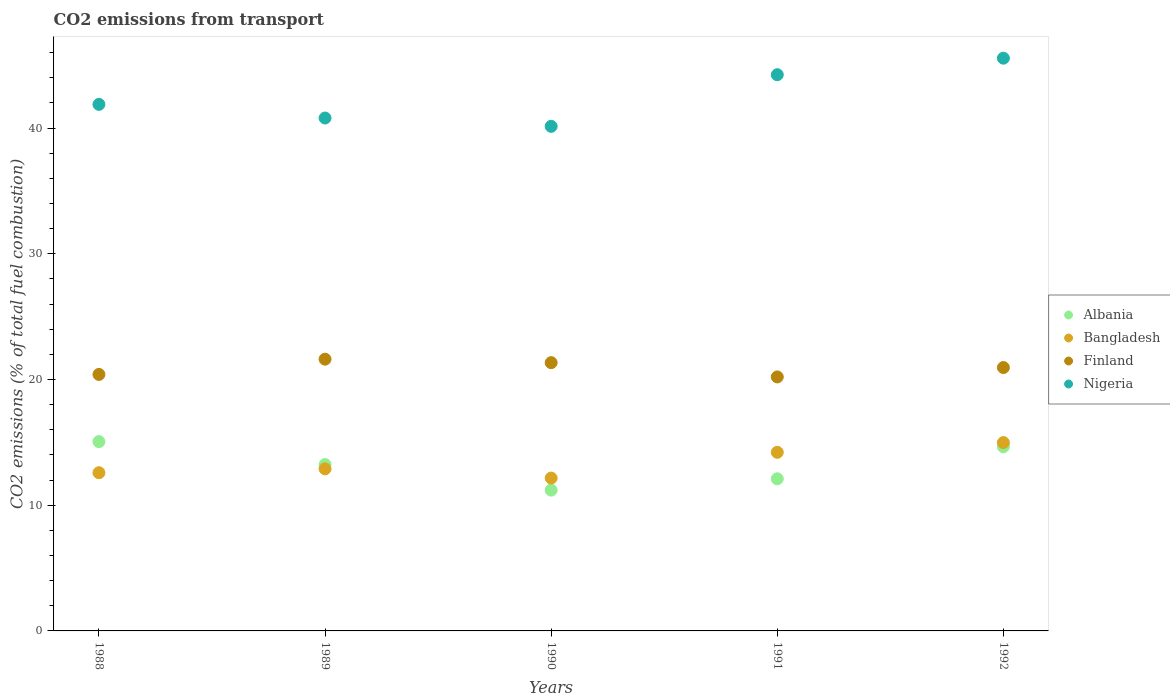What is the total CO2 emitted in Nigeria in 1988?
Give a very brief answer. 41.88. Across all years, what is the maximum total CO2 emitted in Nigeria?
Offer a very short reply. 45.56. Across all years, what is the minimum total CO2 emitted in Finland?
Offer a terse response. 20.2. In which year was the total CO2 emitted in Nigeria maximum?
Your response must be concise. 1992. In which year was the total CO2 emitted in Bangladesh minimum?
Offer a terse response. 1990. What is the total total CO2 emitted in Nigeria in the graph?
Your response must be concise. 212.63. What is the difference between the total CO2 emitted in Finland in 1990 and that in 1992?
Keep it short and to the point. 0.39. What is the difference between the total CO2 emitted in Albania in 1992 and the total CO2 emitted in Finland in 1990?
Your answer should be compact. -6.69. What is the average total CO2 emitted in Finland per year?
Offer a terse response. 20.9. In the year 1991, what is the difference between the total CO2 emitted in Finland and total CO2 emitted in Bangladesh?
Give a very brief answer. 6. In how many years, is the total CO2 emitted in Nigeria greater than 2?
Make the answer very short. 5. What is the ratio of the total CO2 emitted in Bangladesh in 1989 to that in 1992?
Offer a very short reply. 0.86. Is the total CO2 emitted in Bangladesh in 1989 less than that in 1992?
Your answer should be very brief. Yes. What is the difference between the highest and the second highest total CO2 emitted in Finland?
Your answer should be very brief. 0.28. What is the difference between the highest and the lowest total CO2 emitted in Albania?
Make the answer very short. 3.86. Is the sum of the total CO2 emitted in Nigeria in 1988 and 1990 greater than the maximum total CO2 emitted in Albania across all years?
Ensure brevity in your answer.  Yes. Is the total CO2 emitted in Nigeria strictly greater than the total CO2 emitted in Bangladesh over the years?
Offer a very short reply. Yes. Is the total CO2 emitted in Bangladesh strictly less than the total CO2 emitted in Nigeria over the years?
Offer a terse response. Yes. How many dotlines are there?
Offer a very short reply. 4. How many years are there in the graph?
Provide a short and direct response. 5. Are the values on the major ticks of Y-axis written in scientific E-notation?
Ensure brevity in your answer.  No. Does the graph contain any zero values?
Offer a very short reply. No. How many legend labels are there?
Offer a very short reply. 4. How are the legend labels stacked?
Make the answer very short. Vertical. What is the title of the graph?
Provide a short and direct response. CO2 emissions from transport. Does "Nigeria" appear as one of the legend labels in the graph?
Offer a very short reply. Yes. What is the label or title of the Y-axis?
Your answer should be compact. CO2 emissions (% of total fuel combustion). What is the CO2 emissions (% of total fuel combustion) of Albania in 1988?
Offer a very short reply. 15.06. What is the CO2 emissions (% of total fuel combustion) in Bangladesh in 1988?
Provide a short and direct response. 12.58. What is the CO2 emissions (% of total fuel combustion) in Finland in 1988?
Your answer should be compact. 20.4. What is the CO2 emissions (% of total fuel combustion) in Nigeria in 1988?
Your response must be concise. 41.88. What is the CO2 emissions (% of total fuel combustion) in Albania in 1989?
Keep it short and to the point. 13.23. What is the CO2 emissions (% of total fuel combustion) in Bangladesh in 1989?
Keep it short and to the point. 12.9. What is the CO2 emissions (% of total fuel combustion) in Finland in 1989?
Keep it short and to the point. 21.62. What is the CO2 emissions (% of total fuel combustion) in Nigeria in 1989?
Ensure brevity in your answer.  40.8. What is the CO2 emissions (% of total fuel combustion) of Bangladesh in 1990?
Provide a short and direct response. 12.16. What is the CO2 emissions (% of total fuel combustion) of Finland in 1990?
Provide a short and direct response. 21.34. What is the CO2 emissions (% of total fuel combustion) of Nigeria in 1990?
Keep it short and to the point. 40.14. What is the CO2 emissions (% of total fuel combustion) of Albania in 1991?
Your answer should be very brief. 12.1. What is the CO2 emissions (% of total fuel combustion) in Bangladesh in 1991?
Offer a terse response. 14.21. What is the CO2 emissions (% of total fuel combustion) of Finland in 1991?
Offer a very short reply. 20.2. What is the CO2 emissions (% of total fuel combustion) of Nigeria in 1991?
Make the answer very short. 44.24. What is the CO2 emissions (% of total fuel combustion) in Albania in 1992?
Provide a succinct answer. 14.65. What is the CO2 emissions (% of total fuel combustion) in Bangladesh in 1992?
Your response must be concise. 14.98. What is the CO2 emissions (% of total fuel combustion) of Finland in 1992?
Offer a very short reply. 20.95. What is the CO2 emissions (% of total fuel combustion) in Nigeria in 1992?
Your answer should be very brief. 45.56. Across all years, what is the maximum CO2 emissions (% of total fuel combustion) in Albania?
Make the answer very short. 15.06. Across all years, what is the maximum CO2 emissions (% of total fuel combustion) of Bangladesh?
Ensure brevity in your answer.  14.98. Across all years, what is the maximum CO2 emissions (% of total fuel combustion) in Finland?
Your response must be concise. 21.62. Across all years, what is the maximum CO2 emissions (% of total fuel combustion) of Nigeria?
Provide a succinct answer. 45.56. Across all years, what is the minimum CO2 emissions (% of total fuel combustion) in Albania?
Your answer should be compact. 11.2. Across all years, what is the minimum CO2 emissions (% of total fuel combustion) of Bangladesh?
Your answer should be compact. 12.16. Across all years, what is the minimum CO2 emissions (% of total fuel combustion) in Finland?
Your answer should be very brief. 20.2. Across all years, what is the minimum CO2 emissions (% of total fuel combustion) of Nigeria?
Provide a succinct answer. 40.14. What is the total CO2 emissions (% of total fuel combustion) of Albania in the graph?
Your answer should be compact. 66.24. What is the total CO2 emissions (% of total fuel combustion) in Bangladesh in the graph?
Your answer should be very brief. 66.83. What is the total CO2 emissions (% of total fuel combustion) of Finland in the graph?
Your answer should be very brief. 104.51. What is the total CO2 emissions (% of total fuel combustion) of Nigeria in the graph?
Give a very brief answer. 212.63. What is the difference between the CO2 emissions (% of total fuel combustion) of Albania in 1988 and that in 1989?
Your response must be concise. 1.83. What is the difference between the CO2 emissions (% of total fuel combustion) of Bangladesh in 1988 and that in 1989?
Give a very brief answer. -0.31. What is the difference between the CO2 emissions (% of total fuel combustion) of Finland in 1988 and that in 1989?
Keep it short and to the point. -1.21. What is the difference between the CO2 emissions (% of total fuel combustion) of Nigeria in 1988 and that in 1989?
Offer a terse response. 1.09. What is the difference between the CO2 emissions (% of total fuel combustion) of Albania in 1988 and that in 1990?
Your response must be concise. 3.86. What is the difference between the CO2 emissions (% of total fuel combustion) in Bangladesh in 1988 and that in 1990?
Ensure brevity in your answer.  0.43. What is the difference between the CO2 emissions (% of total fuel combustion) of Finland in 1988 and that in 1990?
Offer a very short reply. -0.94. What is the difference between the CO2 emissions (% of total fuel combustion) in Nigeria in 1988 and that in 1990?
Offer a terse response. 1.75. What is the difference between the CO2 emissions (% of total fuel combustion) in Albania in 1988 and that in 1991?
Offer a terse response. 2.96. What is the difference between the CO2 emissions (% of total fuel combustion) of Bangladesh in 1988 and that in 1991?
Provide a succinct answer. -1.62. What is the difference between the CO2 emissions (% of total fuel combustion) of Finland in 1988 and that in 1991?
Your response must be concise. 0.2. What is the difference between the CO2 emissions (% of total fuel combustion) in Nigeria in 1988 and that in 1991?
Your answer should be compact. -2.36. What is the difference between the CO2 emissions (% of total fuel combustion) of Albania in 1988 and that in 1992?
Make the answer very short. 0.41. What is the difference between the CO2 emissions (% of total fuel combustion) in Bangladesh in 1988 and that in 1992?
Make the answer very short. -2.4. What is the difference between the CO2 emissions (% of total fuel combustion) in Finland in 1988 and that in 1992?
Make the answer very short. -0.55. What is the difference between the CO2 emissions (% of total fuel combustion) in Nigeria in 1988 and that in 1992?
Make the answer very short. -3.67. What is the difference between the CO2 emissions (% of total fuel combustion) in Albania in 1989 and that in 1990?
Your answer should be compact. 2.03. What is the difference between the CO2 emissions (% of total fuel combustion) of Bangladesh in 1989 and that in 1990?
Provide a short and direct response. 0.74. What is the difference between the CO2 emissions (% of total fuel combustion) of Finland in 1989 and that in 1990?
Offer a very short reply. 0.28. What is the difference between the CO2 emissions (% of total fuel combustion) of Nigeria in 1989 and that in 1990?
Offer a very short reply. 0.66. What is the difference between the CO2 emissions (% of total fuel combustion) in Albania in 1989 and that in 1991?
Keep it short and to the point. 1.13. What is the difference between the CO2 emissions (% of total fuel combustion) of Bangladesh in 1989 and that in 1991?
Your answer should be very brief. -1.31. What is the difference between the CO2 emissions (% of total fuel combustion) of Finland in 1989 and that in 1991?
Your answer should be very brief. 1.41. What is the difference between the CO2 emissions (% of total fuel combustion) in Nigeria in 1989 and that in 1991?
Your response must be concise. -3.44. What is the difference between the CO2 emissions (% of total fuel combustion) in Albania in 1989 and that in 1992?
Ensure brevity in your answer.  -1.42. What is the difference between the CO2 emissions (% of total fuel combustion) in Bangladesh in 1989 and that in 1992?
Your answer should be very brief. -2.09. What is the difference between the CO2 emissions (% of total fuel combustion) in Finland in 1989 and that in 1992?
Offer a terse response. 0.67. What is the difference between the CO2 emissions (% of total fuel combustion) in Nigeria in 1989 and that in 1992?
Ensure brevity in your answer.  -4.76. What is the difference between the CO2 emissions (% of total fuel combustion) of Albania in 1990 and that in 1991?
Ensure brevity in your answer.  -0.9. What is the difference between the CO2 emissions (% of total fuel combustion) of Bangladesh in 1990 and that in 1991?
Keep it short and to the point. -2.05. What is the difference between the CO2 emissions (% of total fuel combustion) of Finland in 1990 and that in 1991?
Your answer should be compact. 1.14. What is the difference between the CO2 emissions (% of total fuel combustion) in Nigeria in 1990 and that in 1991?
Provide a short and direct response. -4.11. What is the difference between the CO2 emissions (% of total fuel combustion) of Albania in 1990 and that in 1992?
Offer a terse response. -3.45. What is the difference between the CO2 emissions (% of total fuel combustion) in Bangladesh in 1990 and that in 1992?
Your answer should be compact. -2.82. What is the difference between the CO2 emissions (% of total fuel combustion) in Finland in 1990 and that in 1992?
Ensure brevity in your answer.  0.39. What is the difference between the CO2 emissions (% of total fuel combustion) in Nigeria in 1990 and that in 1992?
Offer a very short reply. -5.42. What is the difference between the CO2 emissions (% of total fuel combustion) in Albania in 1991 and that in 1992?
Give a very brief answer. -2.55. What is the difference between the CO2 emissions (% of total fuel combustion) in Bangladesh in 1991 and that in 1992?
Your answer should be very brief. -0.77. What is the difference between the CO2 emissions (% of total fuel combustion) in Finland in 1991 and that in 1992?
Your answer should be very brief. -0.75. What is the difference between the CO2 emissions (% of total fuel combustion) of Nigeria in 1991 and that in 1992?
Make the answer very short. -1.32. What is the difference between the CO2 emissions (% of total fuel combustion) of Albania in 1988 and the CO2 emissions (% of total fuel combustion) of Bangladesh in 1989?
Make the answer very short. 2.16. What is the difference between the CO2 emissions (% of total fuel combustion) of Albania in 1988 and the CO2 emissions (% of total fuel combustion) of Finland in 1989?
Give a very brief answer. -6.56. What is the difference between the CO2 emissions (% of total fuel combustion) in Albania in 1988 and the CO2 emissions (% of total fuel combustion) in Nigeria in 1989?
Your response must be concise. -25.74. What is the difference between the CO2 emissions (% of total fuel combustion) of Bangladesh in 1988 and the CO2 emissions (% of total fuel combustion) of Finland in 1989?
Provide a succinct answer. -9.03. What is the difference between the CO2 emissions (% of total fuel combustion) of Bangladesh in 1988 and the CO2 emissions (% of total fuel combustion) of Nigeria in 1989?
Your response must be concise. -28.21. What is the difference between the CO2 emissions (% of total fuel combustion) in Finland in 1988 and the CO2 emissions (% of total fuel combustion) in Nigeria in 1989?
Keep it short and to the point. -20.4. What is the difference between the CO2 emissions (% of total fuel combustion) in Albania in 1988 and the CO2 emissions (% of total fuel combustion) in Bangladesh in 1990?
Give a very brief answer. 2.9. What is the difference between the CO2 emissions (% of total fuel combustion) in Albania in 1988 and the CO2 emissions (% of total fuel combustion) in Finland in 1990?
Provide a succinct answer. -6.28. What is the difference between the CO2 emissions (% of total fuel combustion) in Albania in 1988 and the CO2 emissions (% of total fuel combustion) in Nigeria in 1990?
Provide a short and direct response. -25.08. What is the difference between the CO2 emissions (% of total fuel combustion) in Bangladesh in 1988 and the CO2 emissions (% of total fuel combustion) in Finland in 1990?
Ensure brevity in your answer.  -8.75. What is the difference between the CO2 emissions (% of total fuel combustion) in Bangladesh in 1988 and the CO2 emissions (% of total fuel combustion) in Nigeria in 1990?
Provide a short and direct response. -27.55. What is the difference between the CO2 emissions (% of total fuel combustion) of Finland in 1988 and the CO2 emissions (% of total fuel combustion) of Nigeria in 1990?
Offer a very short reply. -19.74. What is the difference between the CO2 emissions (% of total fuel combustion) in Albania in 1988 and the CO2 emissions (% of total fuel combustion) in Bangladesh in 1991?
Provide a short and direct response. 0.85. What is the difference between the CO2 emissions (% of total fuel combustion) in Albania in 1988 and the CO2 emissions (% of total fuel combustion) in Finland in 1991?
Offer a very short reply. -5.14. What is the difference between the CO2 emissions (% of total fuel combustion) of Albania in 1988 and the CO2 emissions (% of total fuel combustion) of Nigeria in 1991?
Your answer should be very brief. -29.18. What is the difference between the CO2 emissions (% of total fuel combustion) of Bangladesh in 1988 and the CO2 emissions (% of total fuel combustion) of Finland in 1991?
Make the answer very short. -7.62. What is the difference between the CO2 emissions (% of total fuel combustion) of Bangladesh in 1988 and the CO2 emissions (% of total fuel combustion) of Nigeria in 1991?
Provide a short and direct response. -31.66. What is the difference between the CO2 emissions (% of total fuel combustion) in Finland in 1988 and the CO2 emissions (% of total fuel combustion) in Nigeria in 1991?
Provide a succinct answer. -23.84. What is the difference between the CO2 emissions (% of total fuel combustion) of Albania in 1988 and the CO2 emissions (% of total fuel combustion) of Bangladesh in 1992?
Your answer should be very brief. 0.08. What is the difference between the CO2 emissions (% of total fuel combustion) in Albania in 1988 and the CO2 emissions (% of total fuel combustion) in Finland in 1992?
Make the answer very short. -5.89. What is the difference between the CO2 emissions (% of total fuel combustion) of Albania in 1988 and the CO2 emissions (% of total fuel combustion) of Nigeria in 1992?
Make the answer very short. -30.5. What is the difference between the CO2 emissions (% of total fuel combustion) in Bangladesh in 1988 and the CO2 emissions (% of total fuel combustion) in Finland in 1992?
Provide a succinct answer. -8.37. What is the difference between the CO2 emissions (% of total fuel combustion) of Bangladesh in 1988 and the CO2 emissions (% of total fuel combustion) of Nigeria in 1992?
Keep it short and to the point. -32.98. What is the difference between the CO2 emissions (% of total fuel combustion) of Finland in 1988 and the CO2 emissions (% of total fuel combustion) of Nigeria in 1992?
Your answer should be very brief. -25.16. What is the difference between the CO2 emissions (% of total fuel combustion) of Albania in 1989 and the CO2 emissions (% of total fuel combustion) of Bangladesh in 1990?
Ensure brevity in your answer.  1.07. What is the difference between the CO2 emissions (% of total fuel combustion) in Albania in 1989 and the CO2 emissions (% of total fuel combustion) in Finland in 1990?
Provide a short and direct response. -8.11. What is the difference between the CO2 emissions (% of total fuel combustion) of Albania in 1989 and the CO2 emissions (% of total fuel combustion) of Nigeria in 1990?
Provide a short and direct response. -26.91. What is the difference between the CO2 emissions (% of total fuel combustion) in Bangladesh in 1989 and the CO2 emissions (% of total fuel combustion) in Finland in 1990?
Offer a very short reply. -8.44. What is the difference between the CO2 emissions (% of total fuel combustion) in Bangladesh in 1989 and the CO2 emissions (% of total fuel combustion) in Nigeria in 1990?
Keep it short and to the point. -27.24. What is the difference between the CO2 emissions (% of total fuel combustion) in Finland in 1989 and the CO2 emissions (% of total fuel combustion) in Nigeria in 1990?
Your response must be concise. -18.52. What is the difference between the CO2 emissions (% of total fuel combustion) in Albania in 1989 and the CO2 emissions (% of total fuel combustion) in Bangladesh in 1991?
Your answer should be compact. -0.98. What is the difference between the CO2 emissions (% of total fuel combustion) of Albania in 1989 and the CO2 emissions (% of total fuel combustion) of Finland in 1991?
Make the answer very short. -6.97. What is the difference between the CO2 emissions (% of total fuel combustion) of Albania in 1989 and the CO2 emissions (% of total fuel combustion) of Nigeria in 1991?
Provide a short and direct response. -31.01. What is the difference between the CO2 emissions (% of total fuel combustion) of Bangladesh in 1989 and the CO2 emissions (% of total fuel combustion) of Finland in 1991?
Offer a very short reply. -7.31. What is the difference between the CO2 emissions (% of total fuel combustion) of Bangladesh in 1989 and the CO2 emissions (% of total fuel combustion) of Nigeria in 1991?
Provide a succinct answer. -31.35. What is the difference between the CO2 emissions (% of total fuel combustion) in Finland in 1989 and the CO2 emissions (% of total fuel combustion) in Nigeria in 1991?
Provide a succinct answer. -22.63. What is the difference between the CO2 emissions (% of total fuel combustion) of Albania in 1989 and the CO2 emissions (% of total fuel combustion) of Bangladesh in 1992?
Ensure brevity in your answer.  -1.75. What is the difference between the CO2 emissions (% of total fuel combustion) of Albania in 1989 and the CO2 emissions (% of total fuel combustion) of Finland in 1992?
Your answer should be compact. -7.72. What is the difference between the CO2 emissions (% of total fuel combustion) of Albania in 1989 and the CO2 emissions (% of total fuel combustion) of Nigeria in 1992?
Ensure brevity in your answer.  -32.33. What is the difference between the CO2 emissions (% of total fuel combustion) of Bangladesh in 1989 and the CO2 emissions (% of total fuel combustion) of Finland in 1992?
Make the answer very short. -8.05. What is the difference between the CO2 emissions (% of total fuel combustion) in Bangladesh in 1989 and the CO2 emissions (% of total fuel combustion) in Nigeria in 1992?
Your answer should be very brief. -32.66. What is the difference between the CO2 emissions (% of total fuel combustion) in Finland in 1989 and the CO2 emissions (% of total fuel combustion) in Nigeria in 1992?
Offer a very short reply. -23.94. What is the difference between the CO2 emissions (% of total fuel combustion) in Albania in 1990 and the CO2 emissions (% of total fuel combustion) in Bangladesh in 1991?
Give a very brief answer. -3.01. What is the difference between the CO2 emissions (% of total fuel combustion) of Albania in 1990 and the CO2 emissions (% of total fuel combustion) of Finland in 1991?
Provide a succinct answer. -9. What is the difference between the CO2 emissions (% of total fuel combustion) of Albania in 1990 and the CO2 emissions (% of total fuel combustion) of Nigeria in 1991?
Provide a short and direct response. -33.04. What is the difference between the CO2 emissions (% of total fuel combustion) of Bangladesh in 1990 and the CO2 emissions (% of total fuel combustion) of Finland in 1991?
Your answer should be very brief. -8.04. What is the difference between the CO2 emissions (% of total fuel combustion) of Bangladesh in 1990 and the CO2 emissions (% of total fuel combustion) of Nigeria in 1991?
Give a very brief answer. -32.08. What is the difference between the CO2 emissions (% of total fuel combustion) in Finland in 1990 and the CO2 emissions (% of total fuel combustion) in Nigeria in 1991?
Provide a short and direct response. -22.9. What is the difference between the CO2 emissions (% of total fuel combustion) of Albania in 1990 and the CO2 emissions (% of total fuel combustion) of Bangladesh in 1992?
Provide a succinct answer. -3.78. What is the difference between the CO2 emissions (% of total fuel combustion) of Albania in 1990 and the CO2 emissions (% of total fuel combustion) of Finland in 1992?
Your answer should be very brief. -9.75. What is the difference between the CO2 emissions (% of total fuel combustion) of Albania in 1990 and the CO2 emissions (% of total fuel combustion) of Nigeria in 1992?
Offer a very short reply. -34.36. What is the difference between the CO2 emissions (% of total fuel combustion) of Bangladesh in 1990 and the CO2 emissions (% of total fuel combustion) of Finland in 1992?
Give a very brief answer. -8.79. What is the difference between the CO2 emissions (% of total fuel combustion) of Bangladesh in 1990 and the CO2 emissions (% of total fuel combustion) of Nigeria in 1992?
Provide a succinct answer. -33.4. What is the difference between the CO2 emissions (% of total fuel combustion) of Finland in 1990 and the CO2 emissions (% of total fuel combustion) of Nigeria in 1992?
Provide a succinct answer. -24.22. What is the difference between the CO2 emissions (% of total fuel combustion) of Albania in 1991 and the CO2 emissions (% of total fuel combustion) of Bangladesh in 1992?
Ensure brevity in your answer.  -2.88. What is the difference between the CO2 emissions (% of total fuel combustion) in Albania in 1991 and the CO2 emissions (% of total fuel combustion) in Finland in 1992?
Your answer should be compact. -8.85. What is the difference between the CO2 emissions (% of total fuel combustion) of Albania in 1991 and the CO2 emissions (% of total fuel combustion) of Nigeria in 1992?
Your response must be concise. -33.46. What is the difference between the CO2 emissions (% of total fuel combustion) in Bangladesh in 1991 and the CO2 emissions (% of total fuel combustion) in Finland in 1992?
Offer a terse response. -6.74. What is the difference between the CO2 emissions (% of total fuel combustion) in Bangladesh in 1991 and the CO2 emissions (% of total fuel combustion) in Nigeria in 1992?
Your response must be concise. -31.35. What is the difference between the CO2 emissions (% of total fuel combustion) in Finland in 1991 and the CO2 emissions (% of total fuel combustion) in Nigeria in 1992?
Provide a succinct answer. -25.36. What is the average CO2 emissions (% of total fuel combustion) of Albania per year?
Ensure brevity in your answer.  13.25. What is the average CO2 emissions (% of total fuel combustion) of Bangladesh per year?
Make the answer very short. 13.37. What is the average CO2 emissions (% of total fuel combustion) in Finland per year?
Keep it short and to the point. 20.9. What is the average CO2 emissions (% of total fuel combustion) in Nigeria per year?
Ensure brevity in your answer.  42.53. In the year 1988, what is the difference between the CO2 emissions (% of total fuel combustion) in Albania and CO2 emissions (% of total fuel combustion) in Bangladesh?
Your answer should be compact. 2.48. In the year 1988, what is the difference between the CO2 emissions (% of total fuel combustion) of Albania and CO2 emissions (% of total fuel combustion) of Finland?
Provide a succinct answer. -5.34. In the year 1988, what is the difference between the CO2 emissions (% of total fuel combustion) in Albania and CO2 emissions (% of total fuel combustion) in Nigeria?
Make the answer very short. -26.83. In the year 1988, what is the difference between the CO2 emissions (% of total fuel combustion) of Bangladesh and CO2 emissions (% of total fuel combustion) of Finland?
Your answer should be compact. -7.82. In the year 1988, what is the difference between the CO2 emissions (% of total fuel combustion) of Bangladesh and CO2 emissions (% of total fuel combustion) of Nigeria?
Ensure brevity in your answer.  -29.3. In the year 1988, what is the difference between the CO2 emissions (% of total fuel combustion) of Finland and CO2 emissions (% of total fuel combustion) of Nigeria?
Provide a succinct answer. -21.48. In the year 1989, what is the difference between the CO2 emissions (% of total fuel combustion) in Albania and CO2 emissions (% of total fuel combustion) in Bangladesh?
Make the answer very short. 0.34. In the year 1989, what is the difference between the CO2 emissions (% of total fuel combustion) in Albania and CO2 emissions (% of total fuel combustion) in Finland?
Ensure brevity in your answer.  -8.39. In the year 1989, what is the difference between the CO2 emissions (% of total fuel combustion) of Albania and CO2 emissions (% of total fuel combustion) of Nigeria?
Make the answer very short. -27.57. In the year 1989, what is the difference between the CO2 emissions (% of total fuel combustion) in Bangladesh and CO2 emissions (% of total fuel combustion) in Finland?
Make the answer very short. -8.72. In the year 1989, what is the difference between the CO2 emissions (% of total fuel combustion) of Bangladesh and CO2 emissions (% of total fuel combustion) of Nigeria?
Offer a very short reply. -27.9. In the year 1989, what is the difference between the CO2 emissions (% of total fuel combustion) of Finland and CO2 emissions (% of total fuel combustion) of Nigeria?
Give a very brief answer. -19.18. In the year 1990, what is the difference between the CO2 emissions (% of total fuel combustion) of Albania and CO2 emissions (% of total fuel combustion) of Bangladesh?
Offer a very short reply. -0.96. In the year 1990, what is the difference between the CO2 emissions (% of total fuel combustion) in Albania and CO2 emissions (% of total fuel combustion) in Finland?
Ensure brevity in your answer.  -10.14. In the year 1990, what is the difference between the CO2 emissions (% of total fuel combustion) in Albania and CO2 emissions (% of total fuel combustion) in Nigeria?
Your answer should be very brief. -28.94. In the year 1990, what is the difference between the CO2 emissions (% of total fuel combustion) of Bangladesh and CO2 emissions (% of total fuel combustion) of Finland?
Make the answer very short. -9.18. In the year 1990, what is the difference between the CO2 emissions (% of total fuel combustion) of Bangladesh and CO2 emissions (% of total fuel combustion) of Nigeria?
Offer a very short reply. -27.98. In the year 1990, what is the difference between the CO2 emissions (% of total fuel combustion) in Finland and CO2 emissions (% of total fuel combustion) in Nigeria?
Make the answer very short. -18.8. In the year 1991, what is the difference between the CO2 emissions (% of total fuel combustion) in Albania and CO2 emissions (% of total fuel combustion) in Bangladesh?
Give a very brief answer. -2.11. In the year 1991, what is the difference between the CO2 emissions (% of total fuel combustion) in Albania and CO2 emissions (% of total fuel combustion) in Finland?
Make the answer very short. -8.1. In the year 1991, what is the difference between the CO2 emissions (% of total fuel combustion) of Albania and CO2 emissions (% of total fuel combustion) of Nigeria?
Make the answer very short. -32.14. In the year 1991, what is the difference between the CO2 emissions (% of total fuel combustion) of Bangladesh and CO2 emissions (% of total fuel combustion) of Finland?
Make the answer very short. -6. In the year 1991, what is the difference between the CO2 emissions (% of total fuel combustion) in Bangladesh and CO2 emissions (% of total fuel combustion) in Nigeria?
Your response must be concise. -30.04. In the year 1991, what is the difference between the CO2 emissions (% of total fuel combustion) in Finland and CO2 emissions (% of total fuel combustion) in Nigeria?
Offer a very short reply. -24.04. In the year 1992, what is the difference between the CO2 emissions (% of total fuel combustion) in Albania and CO2 emissions (% of total fuel combustion) in Bangladesh?
Your response must be concise. -0.33. In the year 1992, what is the difference between the CO2 emissions (% of total fuel combustion) of Albania and CO2 emissions (% of total fuel combustion) of Finland?
Your answer should be compact. -6.3. In the year 1992, what is the difference between the CO2 emissions (% of total fuel combustion) of Albania and CO2 emissions (% of total fuel combustion) of Nigeria?
Your response must be concise. -30.91. In the year 1992, what is the difference between the CO2 emissions (% of total fuel combustion) of Bangladesh and CO2 emissions (% of total fuel combustion) of Finland?
Provide a short and direct response. -5.97. In the year 1992, what is the difference between the CO2 emissions (% of total fuel combustion) of Bangladesh and CO2 emissions (% of total fuel combustion) of Nigeria?
Ensure brevity in your answer.  -30.58. In the year 1992, what is the difference between the CO2 emissions (% of total fuel combustion) of Finland and CO2 emissions (% of total fuel combustion) of Nigeria?
Make the answer very short. -24.61. What is the ratio of the CO2 emissions (% of total fuel combustion) of Albania in 1988 to that in 1989?
Your response must be concise. 1.14. What is the ratio of the CO2 emissions (% of total fuel combustion) in Bangladesh in 1988 to that in 1989?
Offer a very short reply. 0.98. What is the ratio of the CO2 emissions (% of total fuel combustion) of Finland in 1988 to that in 1989?
Your answer should be compact. 0.94. What is the ratio of the CO2 emissions (% of total fuel combustion) of Nigeria in 1988 to that in 1989?
Ensure brevity in your answer.  1.03. What is the ratio of the CO2 emissions (% of total fuel combustion) in Albania in 1988 to that in 1990?
Your answer should be very brief. 1.34. What is the ratio of the CO2 emissions (% of total fuel combustion) in Bangladesh in 1988 to that in 1990?
Give a very brief answer. 1.03. What is the ratio of the CO2 emissions (% of total fuel combustion) in Finland in 1988 to that in 1990?
Ensure brevity in your answer.  0.96. What is the ratio of the CO2 emissions (% of total fuel combustion) of Nigeria in 1988 to that in 1990?
Make the answer very short. 1.04. What is the ratio of the CO2 emissions (% of total fuel combustion) in Albania in 1988 to that in 1991?
Your answer should be very brief. 1.24. What is the ratio of the CO2 emissions (% of total fuel combustion) of Bangladesh in 1988 to that in 1991?
Give a very brief answer. 0.89. What is the ratio of the CO2 emissions (% of total fuel combustion) in Finland in 1988 to that in 1991?
Provide a succinct answer. 1.01. What is the ratio of the CO2 emissions (% of total fuel combustion) in Nigeria in 1988 to that in 1991?
Offer a very short reply. 0.95. What is the ratio of the CO2 emissions (% of total fuel combustion) of Albania in 1988 to that in 1992?
Make the answer very short. 1.03. What is the ratio of the CO2 emissions (% of total fuel combustion) of Bangladesh in 1988 to that in 1992?
Offer a terse response. 0.84. What is the ratio of the CO2 emissions (% of total fuel combustion) in Finland in 1988 to that in 1992?
Offer a very short reply. 0.97. What is the ratio of the CO2 emissions (% of total fuel combustion) of Nigeria in 1988 to that in 1992?
Keep it short and to the point. 0.92. What is the ratio of the CO2 emissions (% of total fuel combustion) of Albania in 1989 to that in 1990?
Your response must be concise. 1.18. What is the ratio of the CO2 emissions (% of total fuel combustion) in Bangladesh in 1989 to that in 1990?
Your answer should be very brief. 1.06. What is the ratio of the CO2 emissions (% of total fuel combustion) in Finland in 1989 to that in 1990?
Provide a short and direct response. 1.01. What is the ratio of the CO2 emissions (% of total fuel combustion) in Nigeria in 1989 to that in 1990?
Your response must be concise. 1.02. What is the ratio of the CO2 emissions (% of total fuel combustion) in Albania in 1989 to that in 1991?
Your response must be concise. 1.09. What is the ratio of the CO2 emissions (% of total fuel combustion) of Bangladesh in 1989 to that in 1991?
Offer a very short reply. 0.91. What is the ratio of the CO2 emissions (% of total fuel combustion) of Finland in 1989 to that in 1991?
Offer a very short reply. 1.07. What is the ratio of the CO2 emissions (% of total fuel combustion) of Nigeria in 1989 to that in 1991?
Offer a terse response. 0.92. What is the ratio of the CO2 emissions (% of total fuel combustion) of Albania in 1989 to that in 1992?
Your answer should be very brief. 0.9. What is the ratio of the CO2 emissions (% of total fuel combustion) in Bangladesh in 1989 to that in 1992?
Provide a short and direct response. 0.86. What is the ratio of the CO2 emissions (% of total fuel combustion) of Finland in 1989 to that in 1992?
Make the answer very short. 1.03. What is the ratio of the CO2 emissions (% of total fuel combustion) of Nigeria in 1989 to that in 1992?
Provide a short and direct response. 0.9. What is the ratio of the CO2 emissions (% of total fuel combustion) of Albania in 1990 to that in 1991?
Your answer should be compact. 0.93. What is the ratio of the CO2 emissions (% of total fuel combustion) of Bangladesh in 1990 to that in 1991?
Provide a succinct answer. 0.86. What is the ratio of the CO2 emissions (% of total fuel combustion) in Finland in 1990 to that in 1991?
Provide a short and direct response. 1.06. What is the ratio of the CO2 emissions (% of total fuel combustion) of Nigeria in 1990 to that in 1991?
Your answer should be compact. 0.91. What is the ratio of the CO2 emissions (% of total fuel combustion) in Albania in 1990 to that in 1992?
Offer a very short reply. 0.76. What is the ratio of the CO2 emissions (% of total fuel combustion) of Bangladesh in 1990 to that in 1992?
Keep it short and to the point. 0.81. What is the ratio of the CO2 emissions (% of total fuel combustion) in Finland in 1990 to that in 1992?
Keep it short and to the point. 1.02. What is the ratio of the CO2 emissions (% of total fuel combustion) in Nigeria in 1990 to that in 1992?
Keep it short and to the point. 0.88. What is the ratio of the CO2 emissions (% of total fuel combustion) in Albania in 1991 to that in 1992?
Provide a succinct answer. 0.83. What is the ratio of the CO2 emissions (% of total fuel combustion) in Bangladesh in 1991 to that in 1992?
Offer a very short reply. 0.95. What is the ratio of the CO2 emissions (% of total fuel combustion) of Finland in 1991 to that in 1992?
Make the answer very short. 0.96. What is the ratio of the CO2 emissions (% of total fuel combustion) of Nigeria in 1991 to that in 1992?
Offer a terse response. 0.97. What is the difference between the highest and the second highest CO2 emissions (% of total fuel combustion) of Albania?
Provide a short and direct response. 0.41. What is the difference between the highest and the second highest CO2 emissions (% of total fuel combustion) of Bangladesh?
Offer a very short reply. 0.77. What is the difference between the highest and the second highest CO2 emissions (% of total fuel combustion) of Finland?
Keep it short and to the point. 0.28. What is the difference between the highest and the second highest CO2 emissions (% of total fuel combustion) in Nigeria?
Keep it short and to the point. 1.32. What is the difference between the highest and the lowest CO2 emissions (% of total fuel combustion) of Albania?
Make the answer very short. 3.86. What is the difference between the highest and the lowest CO2 emissions (% of total fuel combustion) of Bangladesh?
Ensure brevity in your answer.  2.82. What is the difference between the highest and the lowest CO2 emissions (% of total fuel combustion) in Finland?
Provide a short and direct response. 1.41. What is the difference between the highest and the lowest CO2 emissions (% of total fuel combustion) in Nigeria?
Make the answer very short. 5.42. 